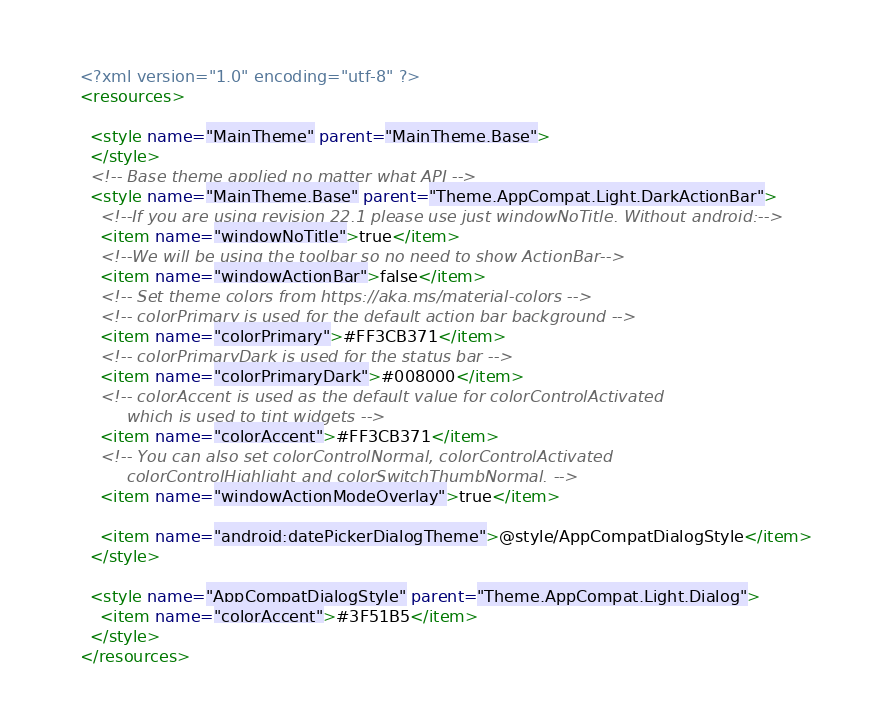<code> <loc_0><loc_0><loc_500><loc_500><_XML_><?xml version="1.0" encoding="utf-8" ?>
<resources>

  <style name="MainTheme" parent="MainTheme.Base">
  </style>
  <!-- Base theme applied no matter what API -->
  <style name="MainTheme.Base" parent="Theme.AppCompat.Light.DarkActionBar">
    <!--If you are using revision 22.1 please use just windowNoTitle. Without android:-->
    <item name="windowNoTitle">true</item>
    <!--We will be using the toolbar so no need to show ActionBar-->
    <item name="windowActionBar">false</item>
    <!-- Set theme colors from https://aka.ms/material-colors -->
    <!-- colorPrimary is used for the default action bar background -->
    <item name="colorPrimary">#FF3CB371</item>
    <!-- colorPrimaryDark is used for the status bar -->
    <item name="colorPrimaryDark">#008000</item>
    <!-- colorAccent is used as the default value for colorControlActivated
         which is used to tint widgets -->
    <item name="colorAccent">#FF3CB371</item>
    <!-- You can also set colorControlNormal, colorControlActivated
         colorControlHighlight and colorSwitchThumbNormal. -->
    <item name="windowActionModeOverlay">true</item>

    <item name="android:datePickerDialogTheme">@style/AppCompatDialogStyle</item>
  </style>

  <style name="AppCompatDialogStyle" parent="Theme.AppCompat.Light.Dialog">
    <item name="colorAccent">#3F51B5</item>
  </style>
</resources>
</code> 